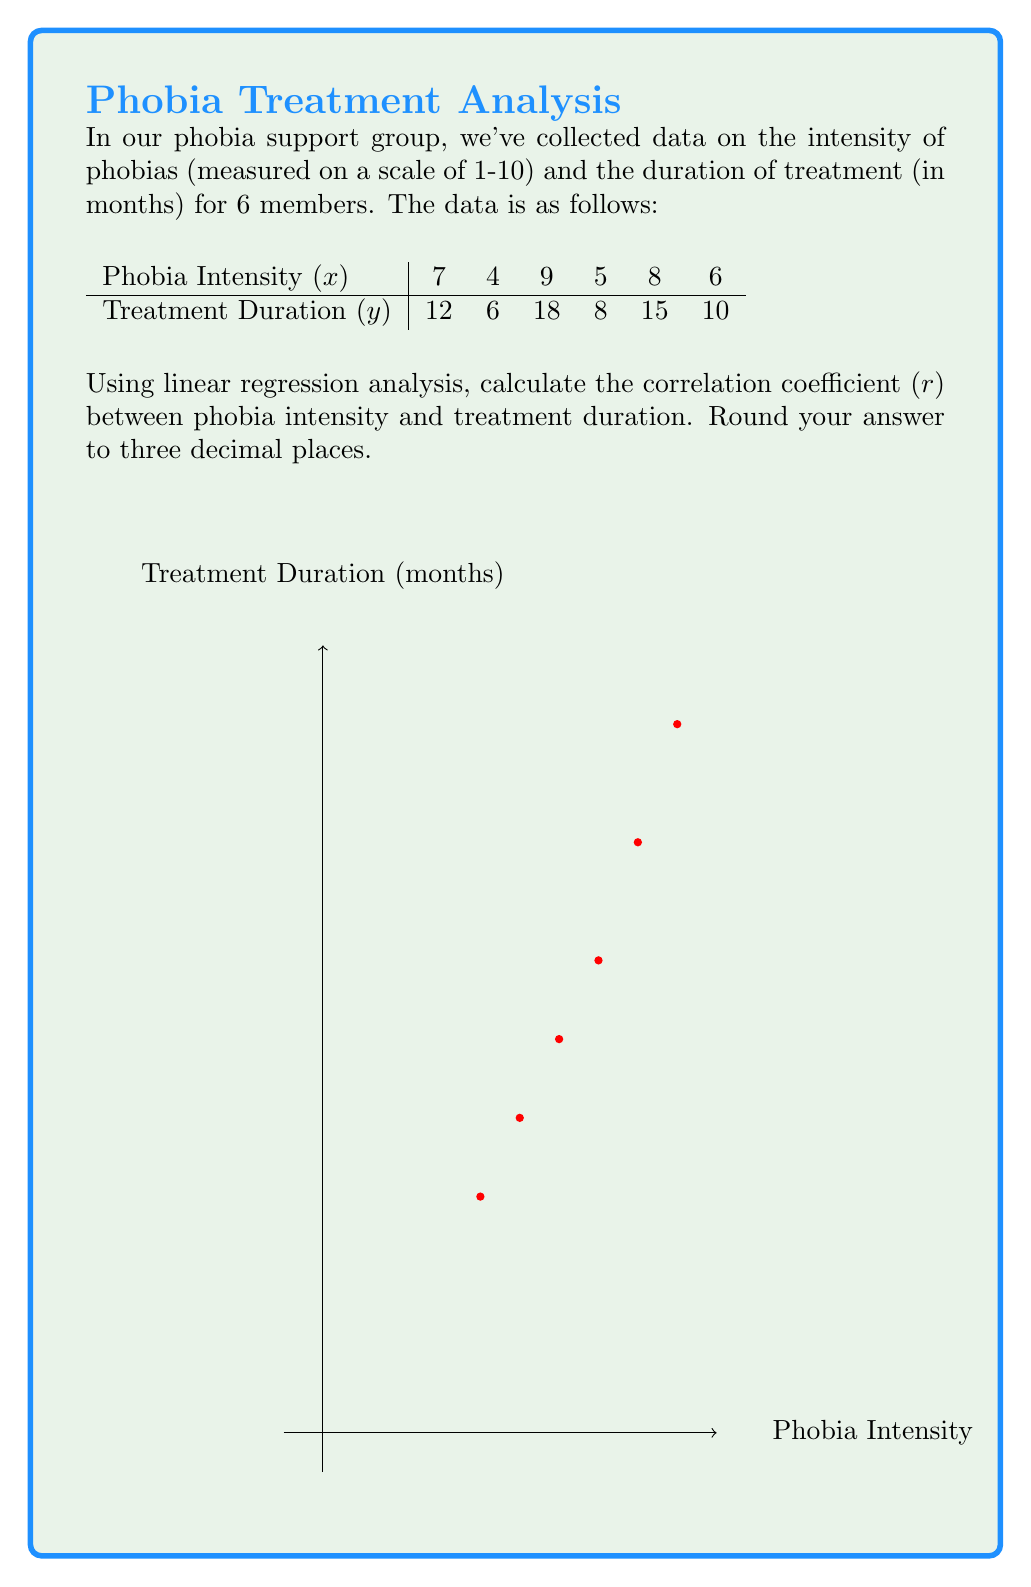Teach me how to tackle this problem. Let's approach this step-by-step:

1) First, we need to calculate the means of x and y:
   $\bar{x} = \frac{7 + 4 + 9 + 5 + 8 + 6}{6} = 6.5$
   $\bar{y} = \frac{12 + 6 + 18 + 8 + 15 + 10}{6} = 11.5$

2) Now, we need to calculate the following sums:
   $\sum (x - \bar{x})(y - \bar{y})$
   $\sum (x - \bar{x})^2$
   $\sum (y - \bar{y})^2$

3) Let's calculate these:
   $\sum (x - \bar{x})(y - \bar{y}) = (7-6.5)(12-11.5) + (4-6.5)(6-11.5) + ... + (6-6.5)(10-11.5) = 34.5$
   $\sum (x - \bar{x})^2 = (7-6.5)^2 + (4-6.5)^2 + ... + (6-6.5)^2 = 17.5$
   $\sum (y - \bar{y})^2 = (12-11.5)^2 + (6-11.5)^2 + ... + (10-11.5)^2 = 98.5$

4) The correlation coefficient is given by the formula:
   
   $r = \frac{\sum (x - \bar{x})(y - \bar{y})}{\sqrt{\sum (x - \bar{x})^2 \sum (y - \bar{y})^2}}$

5) Substituting our values:

   $r = \frac{34.5}{\sqrt{17.5 \times 98.5}} = \frac{34.5}{\sqrt{1723.75}} = \frac{34.5}{41.518} = 0.831$

6) Rounding to three decimal places, we get 0.831.
Answer: $r = 0.831$ 